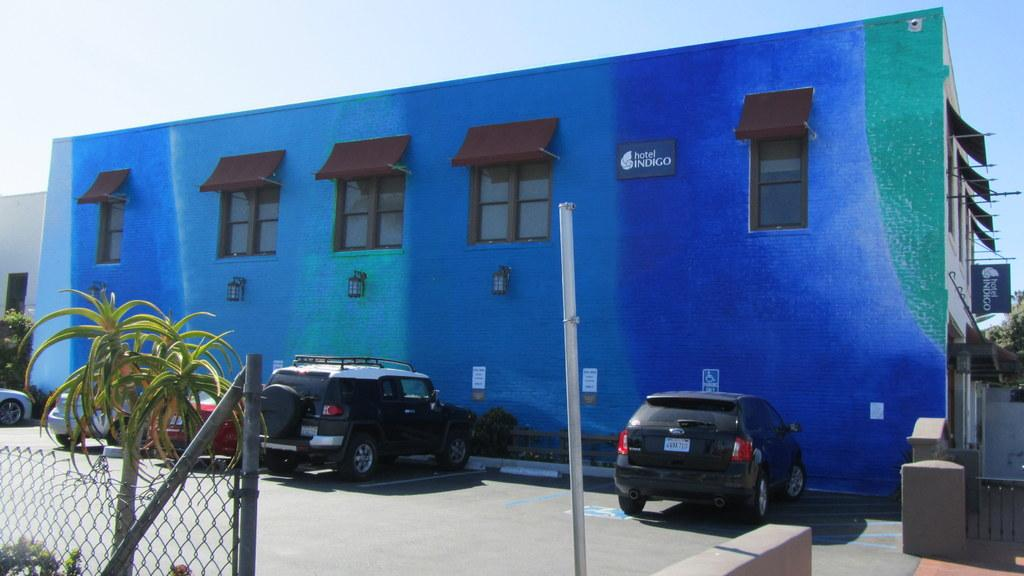What type of structures can be seen in the image? There are houses in the image. What features do the houses have? The houses have windows. What vehicles are present in the image? There are cars in the image. What type of vegetation can be seen in the image? There is a plant in the image. What type of barrier is present in the image? There is a fence in the image. What additional object is present in the image? There is a banner in the image. What is visible at the top of the image? The sky is visible at the top of the image. What type of zinc is being used to construct the houses in the image? There is no information about the materials used to construct the houses in the image. How many heads can be seen on the banner in the image? There are no heads depicted on the banner in the image. 